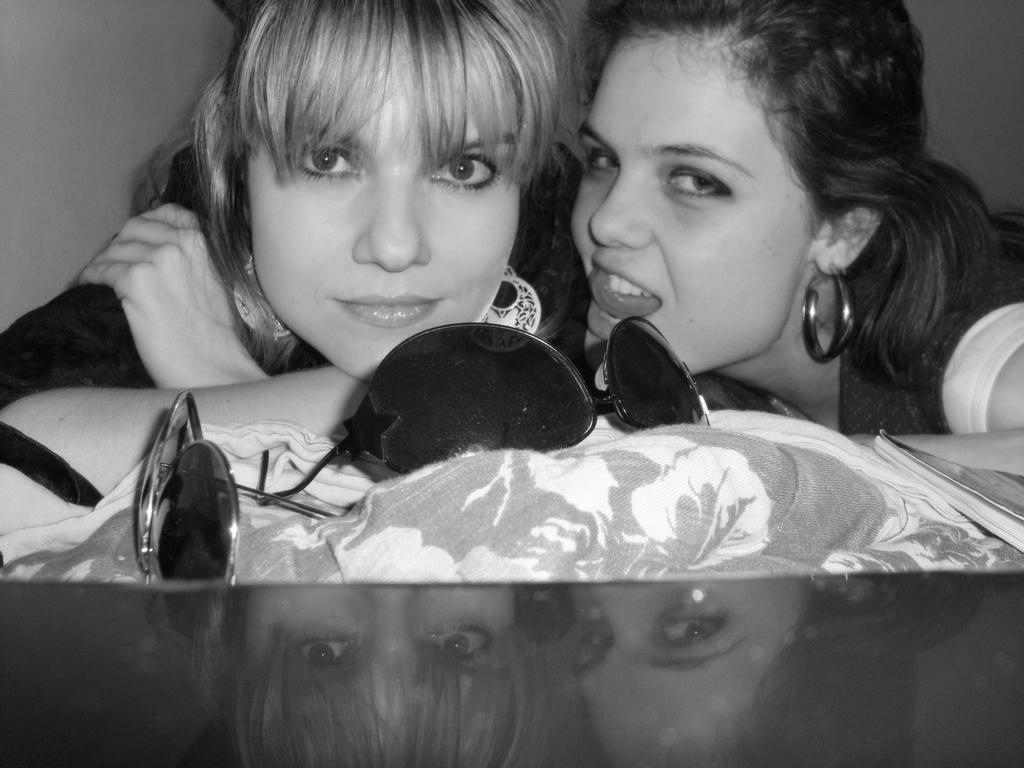How many people are in the image? There are two people in the image. What is in front of the people? There are goggles in front of the people. What object related to reading is visible in the image? There is a book visible in the image. What type of container is present in the image? There is a glass in the image. What is the color scheme of the image? The image is black and white. Can you tell me the name of the girl in the image? There is no girl present in the image; it features two people, both of whom appear to be adults. What type of memory is being stored in the goggles? The goggles in the image are not capable of storing memories; they are simply a piece of equipment being used by the people. 